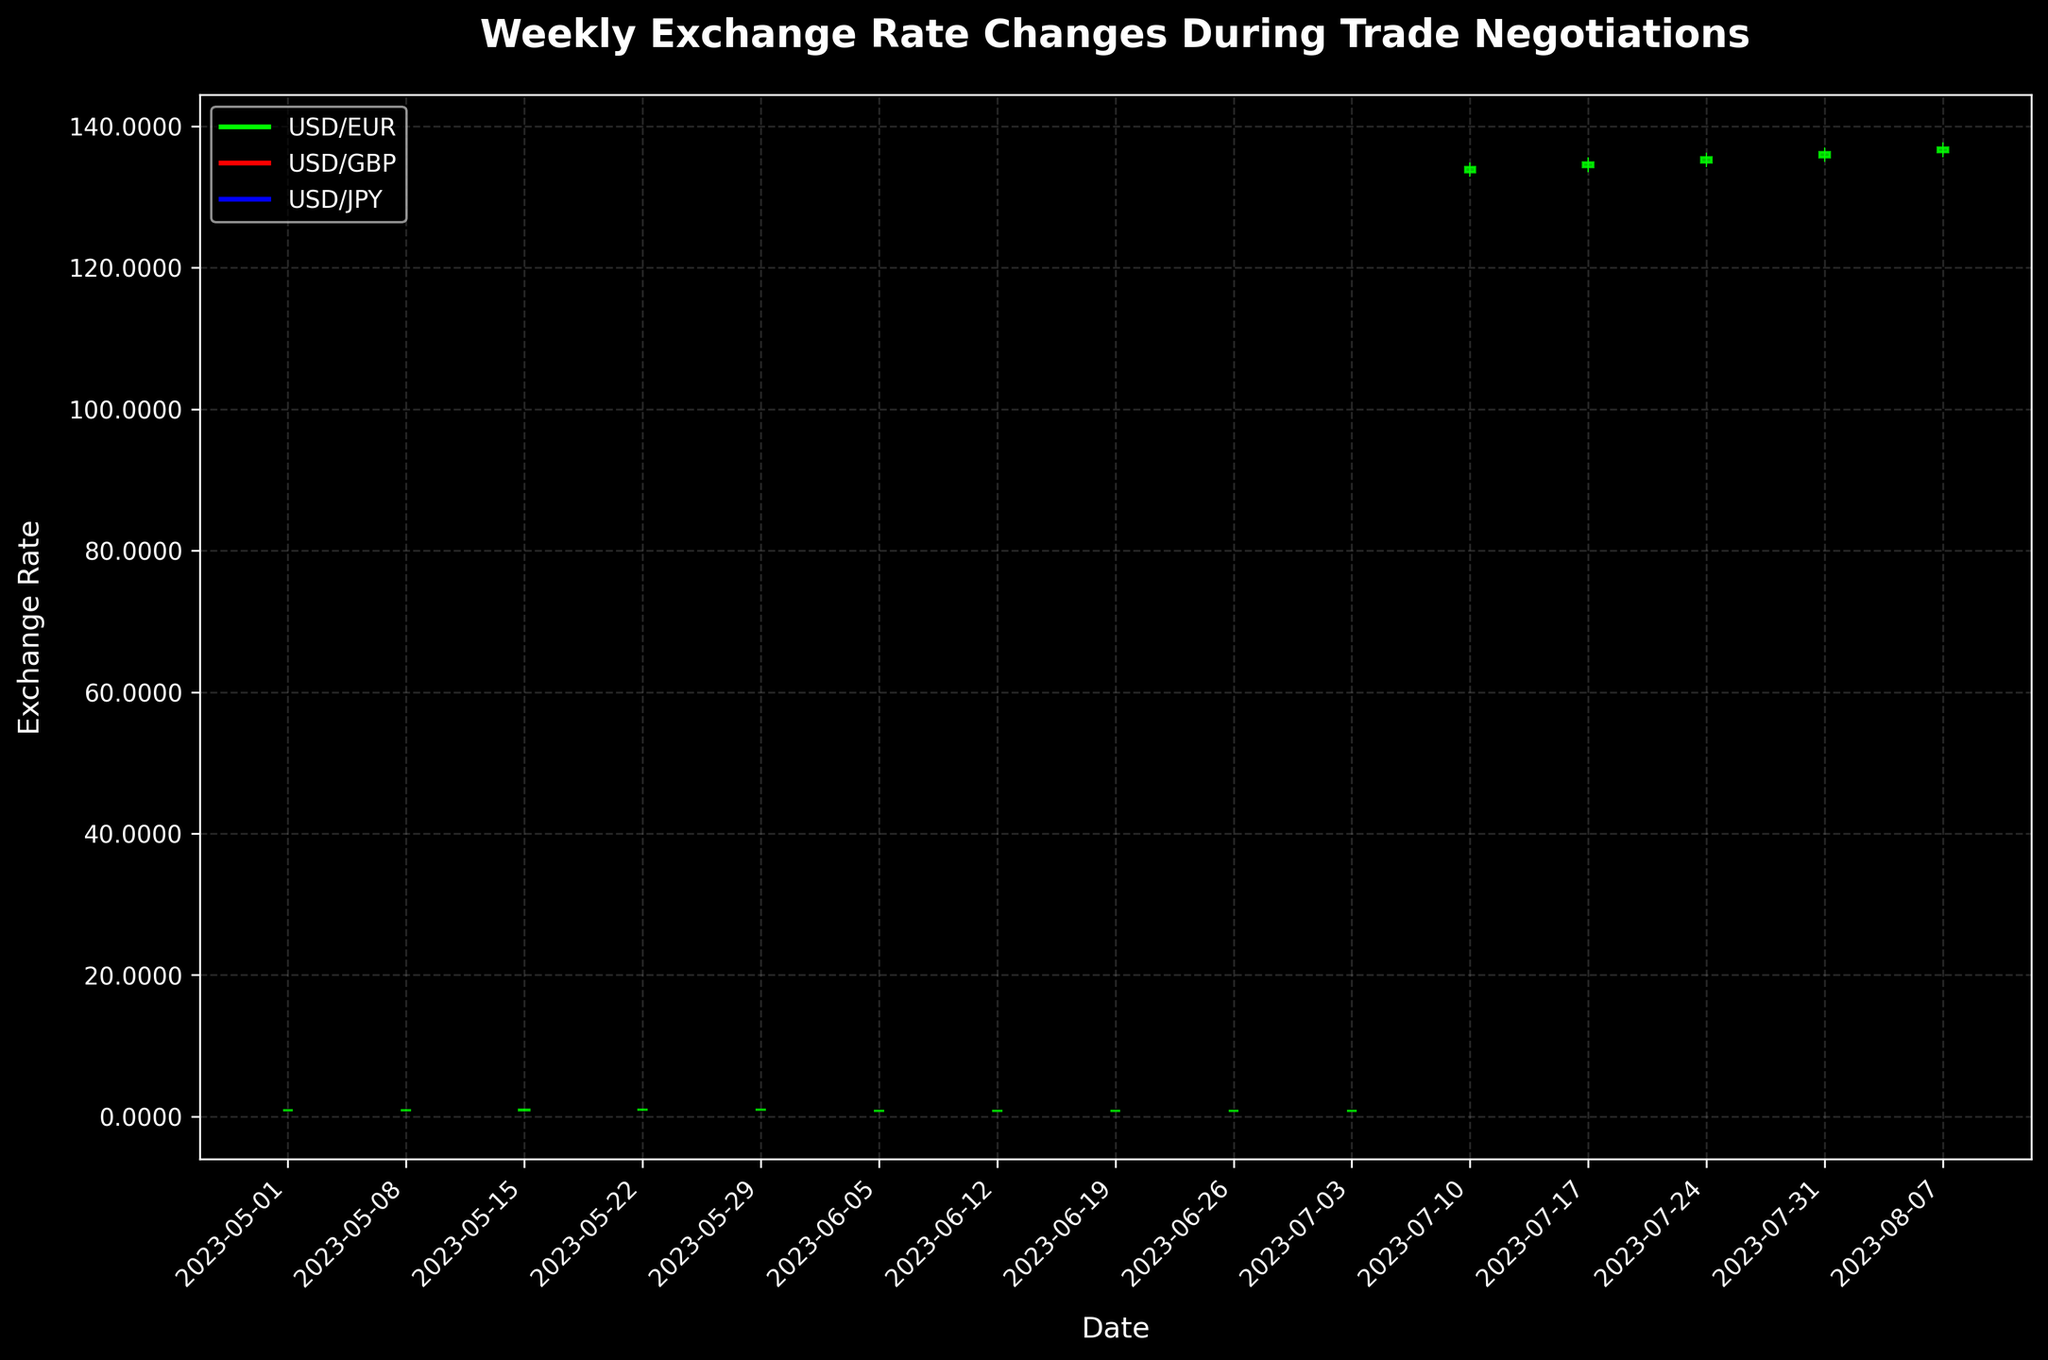What is the title of the figure? The title is usually displayed prominently at the top of the figure. Here, it can be found centered and written in bold text.
Answer: Weekly Exchange Rate Changes During Trade Negotiations Which currency pair shows the highest value overall? The highest value overall can be identified by looking at the highest point across all OHLC charts within the figure. The USD/JPY pair shows the highest value at around 137.60.
Answer: USD/JPY What is the exchange rate range for USD/EUR during the week of May 15, 2023? The exchange rate range can be determined by subtracting the Low value from the High value during the specified week. The High is 0.9280 and the Low is 0.9190, so the range is 0.9280 - 0.9190.
Answer: 0.0090 On which date did the USD/GBP close the week at its highest rate? By examining the Close values for all weeks within the USD/GBP series, we see that the highest Close rate is 0.8130 on July 03, 2023.
Answer: July 03, 2023 When comparing USD/EUR's opening rates throughout May 2023, which week had the lowest opening rate? The opening rates for May 2023 are 0.9150 (May 01), 0.9180 (May 08), 0.9220 (May 15), 0.9250 (May 22), and 0.9270 (May 29). The lowest among these is 0.9150 on May 01, 2023.
Answer: May 01, 2023 How did the closing rate for USD/JPY change from July 17, 2023, to July 24, 2023? The closing rate on July 17, 2023, is 134.90, and on July 24, 2023, it is 135.60. The change can be calculated as 135.60 - 134.90.
Answer: 0.70 Which currency pair had the most volatile week and on what date? (Volatility defined as the largest differences between High and Low values) To find the most volatile week, calculate the High - Low for each currency pair across all weeks, and identify the largest difference. The most volatile is USD/JPY on August 07, 2023, with a difference of 137.60 - 135.70.
Answer: USD/JPY on August 07, 2023 